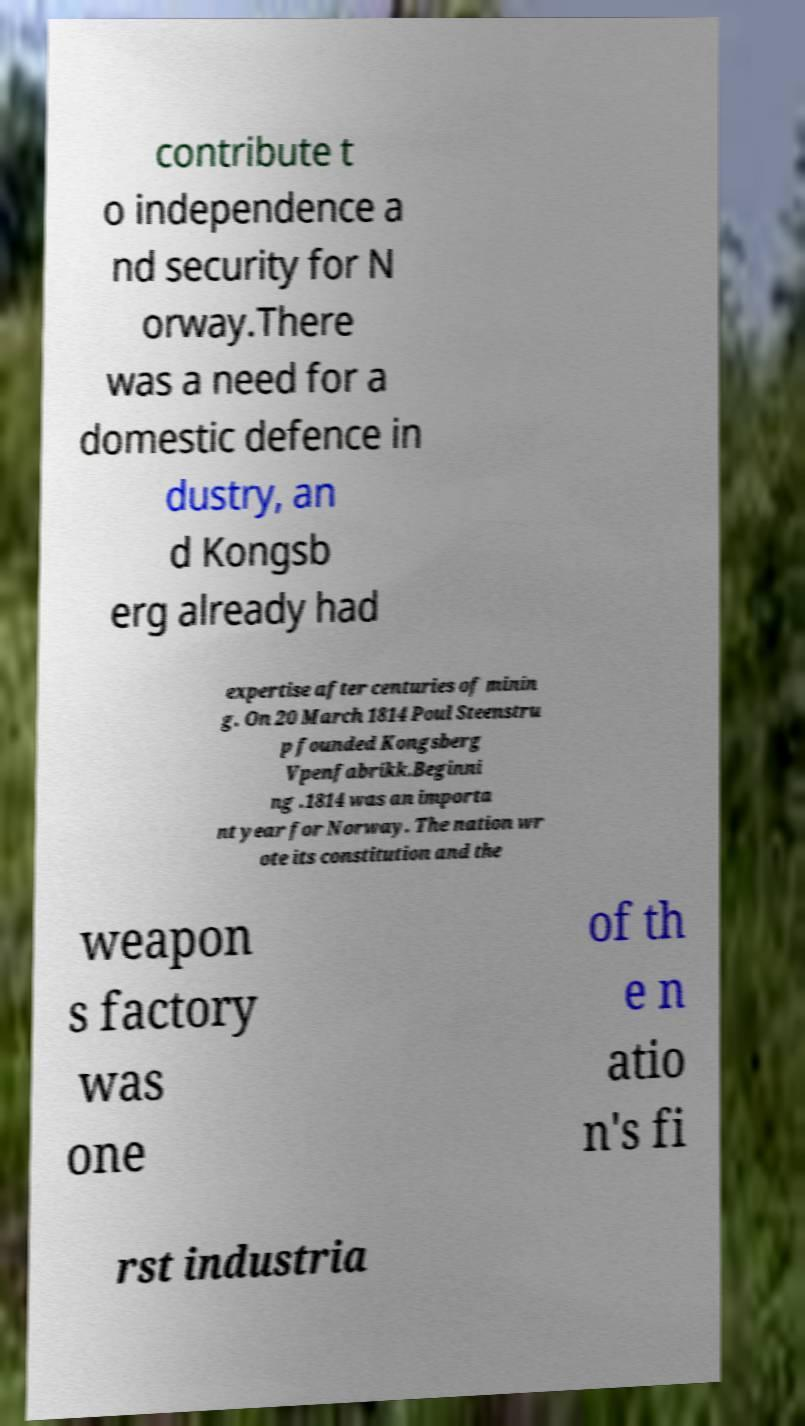What messages or text are displayed in this image? I need them in a readable, typed format. contribute t o independence a nd security for N orway.There was a need for a domestic defence in dustry, an d Kongsb erg already had expertise after centuries of minin g. On 20 March 1814 Poul Steenstru p founded Kongsberg Vpenfabrikk.Beginni ng .1814 was an importa nt year for Norway. The nation wr ote its constitution and the weapon s factory was one of th e n atio n's fi rst industria 